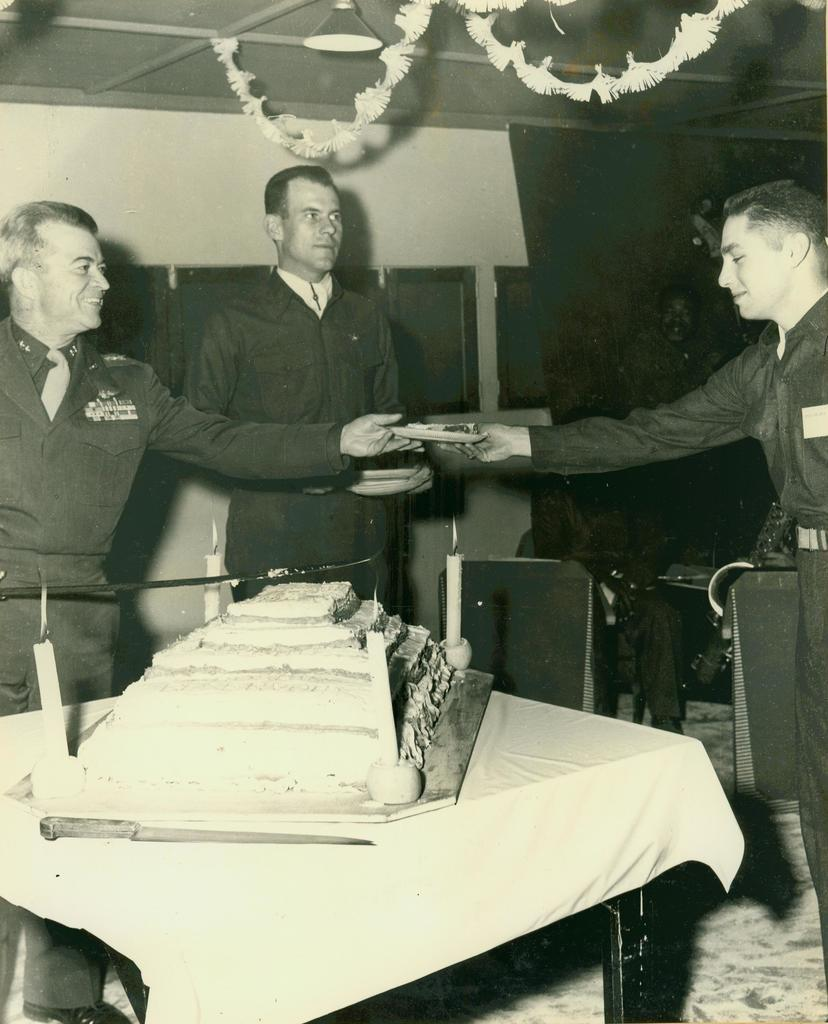How many people are present in the image? There are three people standing in the image. What is on the table in the image? There is a cake on a table in the image. Are there any decorations on the cake? The presence of candles on the table suggests that there may be candles on the cake as well. What type of interest can be heard in the voice of the person blowing out the candles? There is no voice or sound present in the image, so it is not possible to determine the type of interest in the person's voice. 